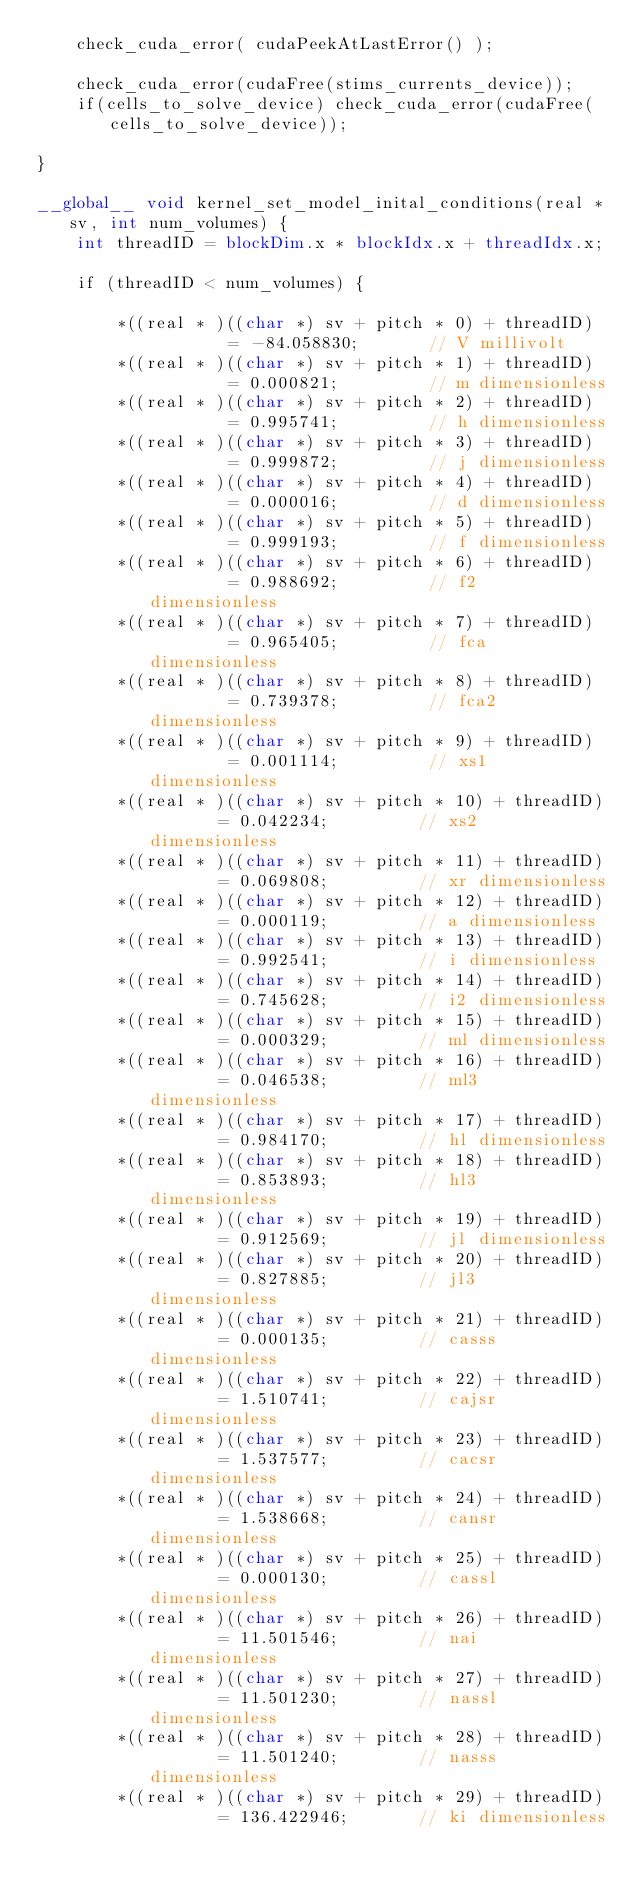Convert code to text. <code><loc_0><loc_0><loc_500><loc_500><_Cuda_>    check_cuda_error( cudaPeekAtLastError() );

    check_cuda_error(cudaFree(stims_currents_device));
    if(cells_to_solve_device) check_cuda_error(cudaFree(cells_to_solve_device));

}

__global__ void kernel_set_model_inital_conditions(real *sv, int num_volumes) {
    int threadID = blockDim.x * blockIdx.x + threadIdx.x;

    if (threadID < num_volumes) {

        *((real * )((char *) sv + pitch * 0) + threadID)		= -84.058830;       // V millivolt
        *((real * )((char *) sv + pitch * 1) + threadID)		= 0.000821;         // m dimensionless
        *((real * )((char *) sv + pitch * 2) + threadID)		= 0.995741;         // h dimensionless
        *((real * )((char *) sv + pitch * 3) + threadID)		= 0.999872;         // j dimensionless
        *((real * )((char *) sv + pitch * 4) + threadID)		= 0.000016;         // d dimensionless
        *((real * )((char *) sv + pitch * 5) + threadID)		= 0.999193;         // f dimensionless
        *((real * )((char *) sv + pitch * 6) + threadID)		= 0.988692;         // f2 dimensionless
        *((real * )((char *) sv + pitch * 7) + threadID)		= 0.965405;         // fca dimensionless
        *((real * )((char *) sv + pitch * 8) + threadID)	    = 0.739378;         // fca2 dimensionless
        *((real * )((char *) sv + pitch * 9) + threadID)		= 0.001114;         // xs1 dimensionless
        *((real * )((char *) sv + pitch * 10) + threadID)		= 0.042234;         // xs2 dimensionless
        *((real * )((char *) sv + pitch * 11) + threadID)		= 0.069808;         // xr dimensionless
        *((real * )((char *) sv + pitch * 12) + threadID)		= 0.000119;         // a dimensionless
        *((real * )((char *) sv + pitch * 13) + threadID)		= 0.992541;         // i dimensionless
        *((real * )((char *) sv + pitch * 14) + threadID)		= 0.745628;         // i2 dimensionless
        *((real * )((char *) sv + pitch * 15) + threadID)		= 0.000329;         // ml dimensionless
        *((real * )((char *) sv + pitch * 16) + threadID)		= 0.046538;         // ml3 dimensionless
        *((real * )((char *) sv + pitch * 17) + threadID)		= 0.984170;         // hl dimensionless
        *((real * )((char *) sv + pitch * 18) + threadID)		= 0.853893;         // hl3 dimensionless
        *((real * )((char *) sv + pitch * 19) + threadID)		= 0.912569;         // jl dimensionless
        *((real * )((char *) sv + pitch * 20) + threadID)		= 0.827885;         // jl3 dimensionless
        *((real * )((char *) sv + pitch * 21) + threadID)	    = 0.000135;         // casss dimensionless
        *((real * )((char *) sv + pitch * 22) + threadID)	    = 1.510741;         // cajsr dimensionless
        *((real * )((char *) sv + pitch * 23) + threadID)	    = 1.537577;         // cacsr dimensionless
        *((real * )((char *) sv + pitch * 24) + threadID)	    = 1.538668;         // cansr dimensionless
        *((real * )((char *) sv + pitch * 25) + threadID)	    = 0.000130;         // cassl dimensionless
        *((real * )((char *) sv + pitch * 26) + threadID)	    = 11.501546;        // nai dimensionless
        *((real * )((char *) sv + pitch * 27) + threadID)	    = 11.501230;        // nassl dimensionless
        *((real * )((char *) sv + pitch * 28) + threadID)	    = 11.501240;        // nasss dimensionless
        *((real * )((char *) sv + pitch * 29) + threadID)		= 136.422946;       // ki dimensionless</code> 